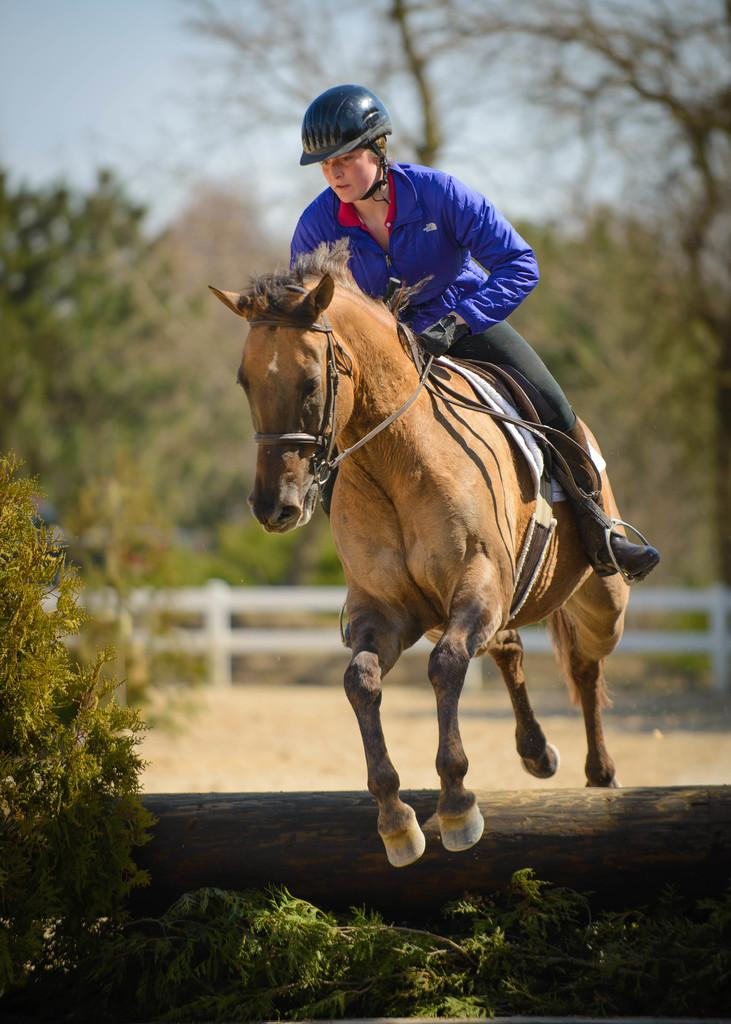What object can be seen on the ground in the image? There is a wooden log in the image. What is the person in the image doing? The person is sitting on a horse in the image. What can be seen in the background of the image? The ground, a fence, trees, and the sky are visible in the background of the image. How many books are stacked on the wooden log in the image? There are no books present in the image; it features a person sitting on a horse and a wooden log on the ground. What type of yam is being rolled by the person in the image? There is no yam or rolling activity present in the image. 